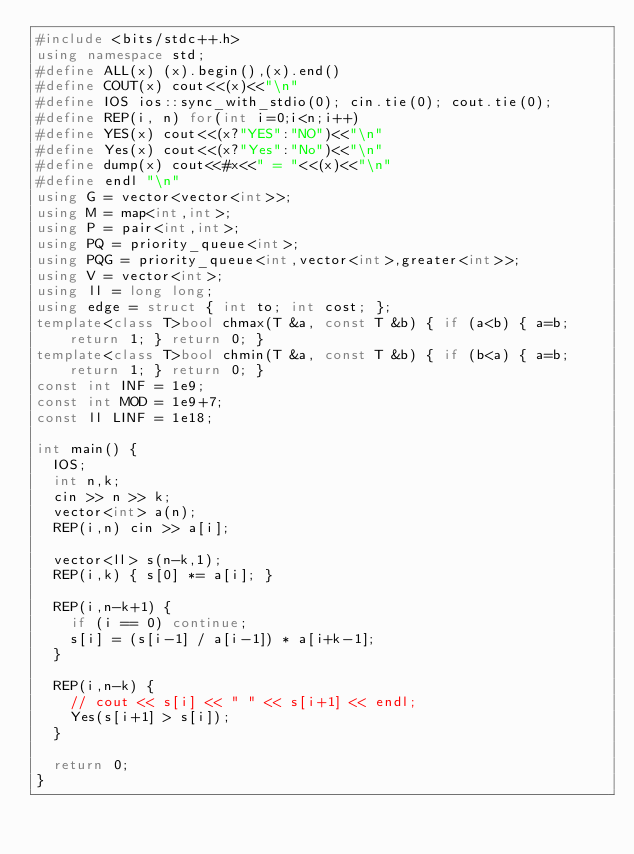Convert code to text. <code><loc_0><loc_0><loc_500><loc_500><_C++_>#include <bits/stdc++.h>
using namespace std;
#define ALL(x) (x).begin(),(x).end()
#define COUT(x) cout<<(x)<<"\n"
#define IOS ios::sync_with_stdio(0); cin.tie(0); cout.tie(0);
#define REP(i, n) for(int i=0;i<n;i++)
#define YES(x) cout<<(x?"YES":"NO")<<"\n"
#define Yes(x) cout<<(x?"Yes":"No")<<"\n"
#define dump(x) cout<<#x<<" = "<<(x)<<"\n"
#define endl "\n"
using G = vector<vector<int>>;
using M = map<int,int>;
using P = pair<int,int>;
using PQ = priority_queue<int>;
using PQG = priority_queue<int,vector<int>,greater<int>>;
using V = vector<int>;
using ll = long long;
using edge = struct { int to; int cost; };
template<class T>bool chmax(T &a, const T &b) { if (a<b) { a=b; return 1; } return 0; }
template<class T>bool chmin(T &a, const T &b) { if (b<a) { a=b; return 1; } return 0; }
const int INF = 1e9;
const int MOD = 1e9+7;
const ll LINF = 1e18;

int main() {
  IOS;
  int n,k;
  cin >> n >> k;
  vector<int> a(n);
  REP(i,n) cin >> a[i];

  vector<ll> s(n-k,1);
  REP(i,k) { s[0] *= a[i]; }

  REP(i,n-k+1) {
    if (i == 0) continue;
    s[i] = (s[i-1] / a[i-1]) * a[i+k-1];
  }

  REP(i,n-k) {
    // cout << s[i] << " " << s[i+1] << endl;
    Yes(s[i+1] > s[i]);
  }

  return 0;
}
</code> 